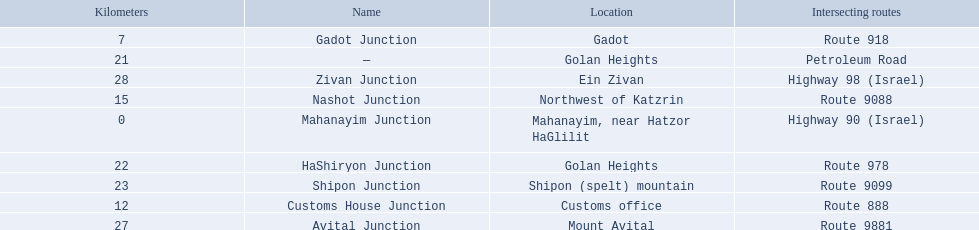Would you be able to parse every entry in this table? {'header': ['Kilometers', 'Name', 'Location', 'Intersecting routes'], 'rows': [['7', 'Gadot Junction', 'Gadot', 'Route 918'], ['21', '—', 'Golan Heights', 'Petroleum Road'], ['28', 'Zivan Junction', 'Ein Zivan', 'Highway 98 (Israel)'], ['15', 'Nashot Junction', 'Northwest of Katzrin', 'Route 9088'], ['0', 'Mahanayim Junction', 'Mahanayim, near Hatzor HaGlilit', 'Highway 90 (Israel)'], ['22', 'HaShiryon Junction', 'Golan Heights', 'Route 978'], ['23', 'Shipon Junction', 'Shipon (spelt) mountain', 'Route 9099'], ['12', 'Customs House Junction', 'Customs office', 'Route 888'], ['27', 'Avital Junction', 'Mount Avital', 'Route 9881']]} What are all of the junction names? Mahanayim Junction, Gadot Junction, Customs House Junction, Nashot Junction, —, HaShiryon Junction, Shipon Junction, Avital Junction, Zivan Junction. What are their locations in kilometers? 0, 7, 12, 15, 21, 22, 23, 27, 28. Between shipon and avital, whicih is nashot closer to? Shipon Junction. 